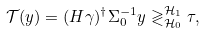<formula> <loc_0><loc_0><loc_500><loc_500>\mathcal { T } ( y ) = ( H \gamma ) ^ { \dagger } \Sigma _ { 0 } ^ { - 1 } y \gtrless _ { \mathcal { H } _ { 0 } } ^ { \mathcal { H } _ { 1 } } \tau ,</formula> 